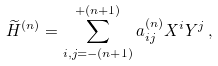<formula> <loc_0><loc_0><loc_500><loc_500>\widetilde { H } ^ { ( n ) } = \sum _ { i , j = - ( n + 1 ) } ^ { + ( n + 1 ) } a _ { i j } ^ { ( n ) } X ^ { i } Y ^ { j } \, ,</formula> 